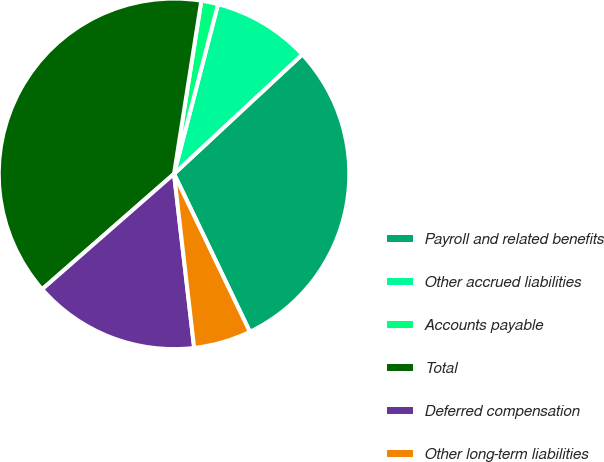<chart> <loc_0><loc_0><loc_500><loc_500><pie_chart><fcel>Payroll and related benefits<fcel>Other accrued liabilities<fcel>Accounts payable<fcel>Total<fcel>Deferred compensation<fcel>Other long-term liabilities<nl><fcel>29.81%<fcel>9.03%<fcel>1.55%<fcel>38.93%<fcel>15.39%<fcel>5.29%<nl></chart> 